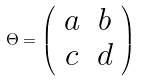Convert formula to latex. <formula><loc_0><loc_0><loc_500><loc_500>\Theta = \left ( \begin{array} { c c } a & b \\ c & d \end{array} \right )</formula> 